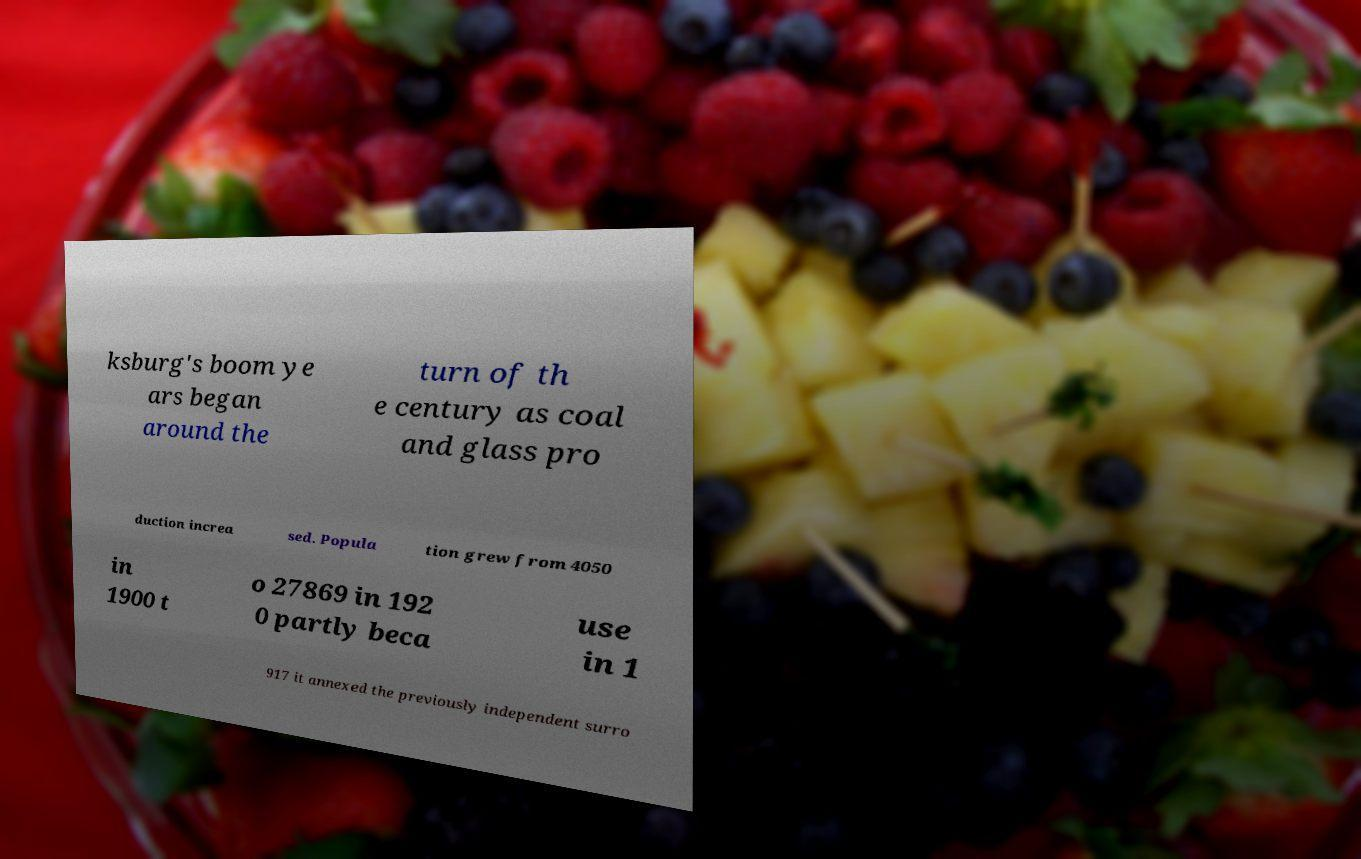Could you extract and type out the text from this image? ksburg's boom ye ars began around the turn of th e century as coal and glass pro duction increa sed. Popula tion grew from 4050 in 1900 t o 27869 in 192 0 partly beca use in 1 917 it annexed the previously independent surro 